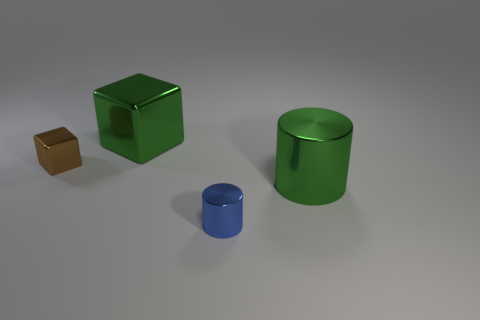Add 1 yellow cubes. How many objects exist? 5 Add 1 large green cylinders. How many large green cylinders are left? 2 Add 1 tiny cyan shiny balls. How many tiny cyan shiny balls exist? 1 Subtract 1 brown blocks. How many objects are left? 3 Subtract all tiny blue metal things. Subtract all large red blocks. How many objects are left? 3 